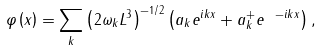<formula> <loc_0><loc_0><loc_500><loc_500>\varphi \left ( x \right ) = \sum _ { k } \left ( 2 \omega _ { k } L ^ { 3 } \right ) ^ { - 1 / 2 } \left ( a _ { k } e ^ { i k x } + a _ { k } ^ { + } e { \ } ^ { - i k x } \right ) ,</formula> 